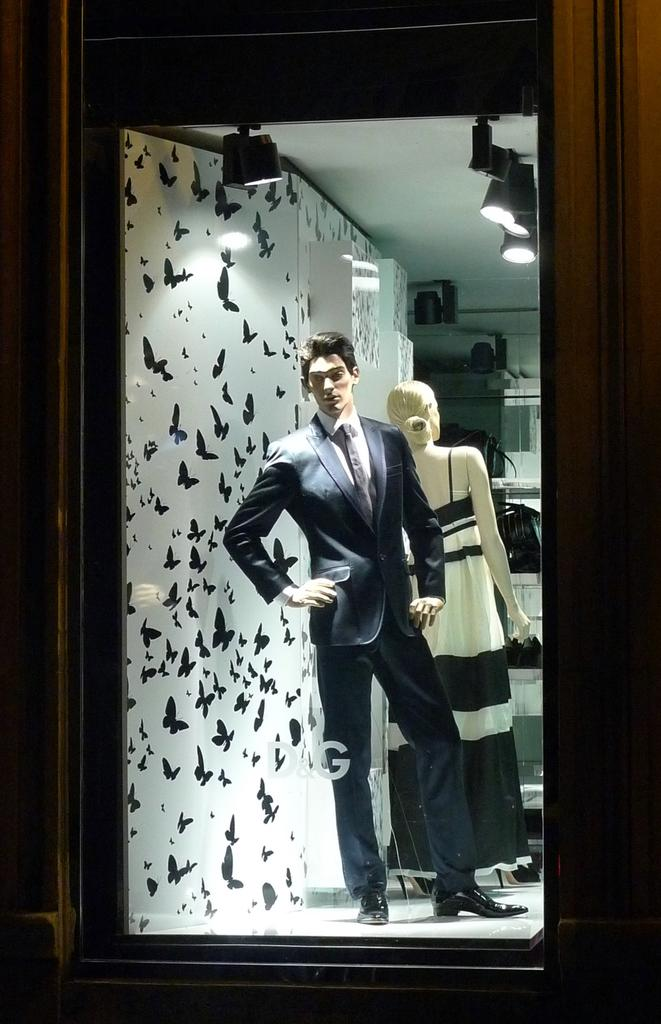What are the main subjects depicted in the image? There is a depiction of a man and a woman in the image. What can be seen in the background of the image? There is a wall in the background of the image. What type of wire is being used to hold up the produce in the image? There is no wire or produce present in the image; it only features a depiction of a man and a woman with a wall in the background. 